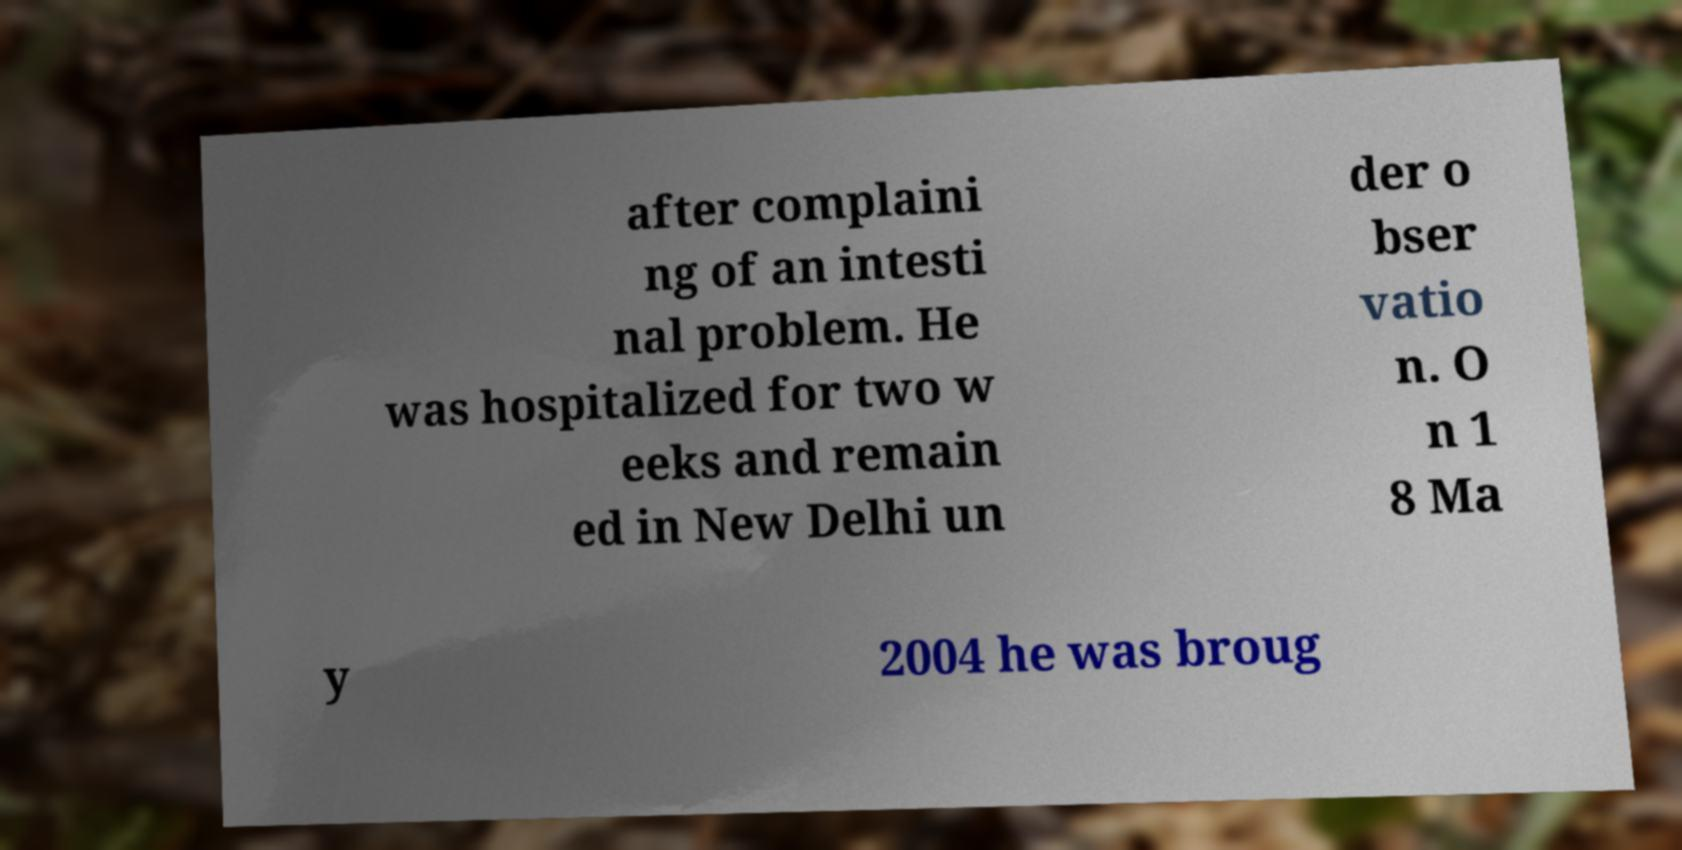Can you accurately transcribe the text from the provided image for me? after complaini ng of an intesti nal problem. He was hospitalized for two w eeks and remain ed in New Delhi un der o bser vatio n. O n 1 8 Ma y 2004 he was broug 